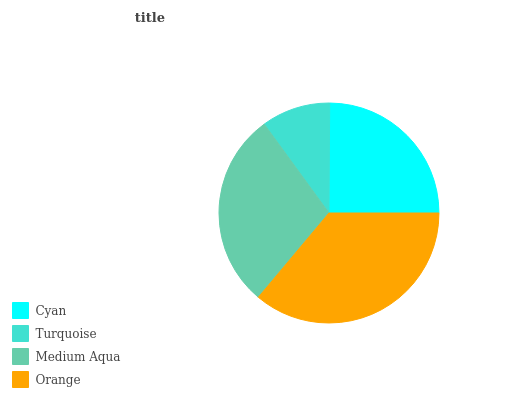Is Turquoise the minimum?
Answer yes or no. Yes. Is Orange the maximum?
Answer yes or no. Yes. Is Medium Aqua the minimum?
Answer yes or no. No. Is Medium Aqua the maximum?
Answer yes or no. No. Is Medium Aqua greater than Turquoise?
Answer yes or no. Yes. Is Turquoise less than Medium Aqua?
Answer yes or no. Yes. Is Turquoise greater than Medium Aqua?
Answer yes or no. No. Is Medium Aqua less than Turquoise?
Answer yes or no. No. Is Medium Aqua the high median?
Answer yes or no. Yes. Is Cyan the low median?
Answer yes or no. Yes. Is Turquoise the high median?
Answer yes or no. No. Is Turquoise the low median?
Answer yes or no. No. 